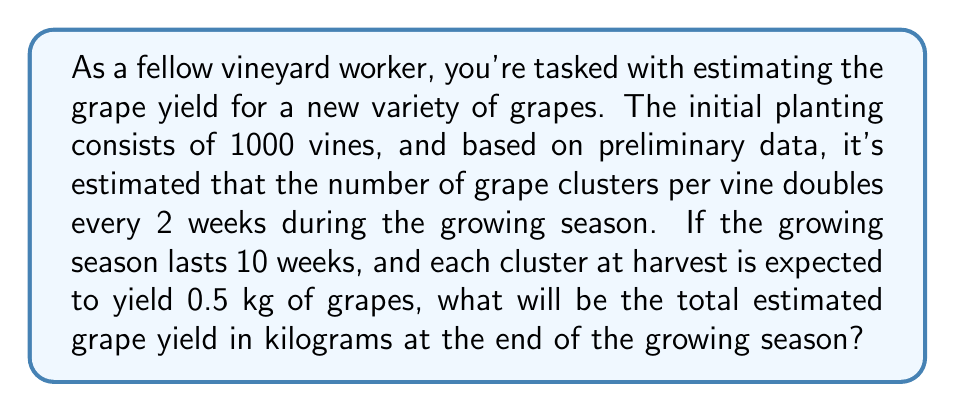What is the answer to this math problem? Let's approach this problem step-by-step using an exponential growth model:

1) First, we need to determine the number of times the grape clusters will double during the 10-week growing season:
   $\text{Number of doublings} = \frac{\text{Total weeks}}{\text{Weeks per doubling}} = \frac{10}{2} = 5$

2) Now, we can set up our exponential growth equation:
   $\text{Final number of clusters per vine} = \text{Initial clusters} \times 2^{\text{Number of doublings}}$

3) Let's assume each vine starts with 1 cluster. Then:
   $\text{Final number of clusters per vine} = 1 \times 2^5 = 32$

4) To get the total number of clusters, we multiply by the number of vines:
   $\text{Total clusters} = 32 \times 1000 = 32,000$

5) Finally, to get the yield in kilograms, we multiply by the yield per cluster:
   $\text{Total yield} = 32,000 \times 0.5\text{ kg} = 16,000\text{ kg}$

Therefore, the estimated grape yield at the end of the growing season is 16,000 kg.
Answer: 16,000 kg 